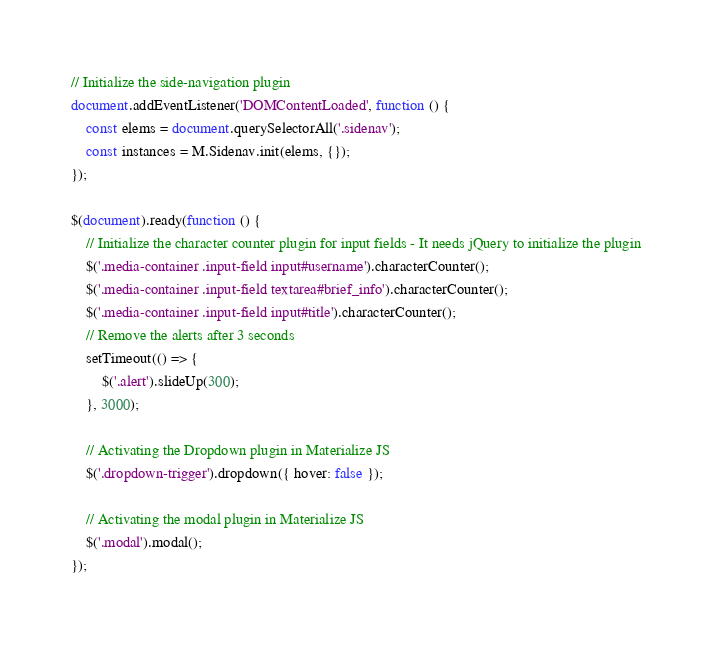Convert code to text. <code><loc_0><loc_0><loc_500><loc_500><_JavaScript_>// Initialize the side-navigation plugin
document.addEventListener('DOMContentLoaded', function () {
    const elems = document.querySelectorAll('.sidenav');
    const instances = M.Sidenav.init(elems, {});
});

$(document).ready(function () {
    // Initialize the character counter plugin for input fields - It needs jQuery to initialize the plugin
    $('.media-container .input-field input#username').characterCounter();
    $('.media-container .input-field textarea#brief_info').characterCounter();
    $('.media-container .input-field input#title').characterCounter();
    // Remove the alerts after 3 seconds
    setTimeout(() => {
        $('.alert').slideUp(300);
    }, 3000);

    // Activating the Dropdown plugin in Materialize JS
    $('.dropdown-trigger').dropdown({ hover: false });

    // Activating the modal plugin in Materialize JS
    $('.modal').modal();
});
</code> 